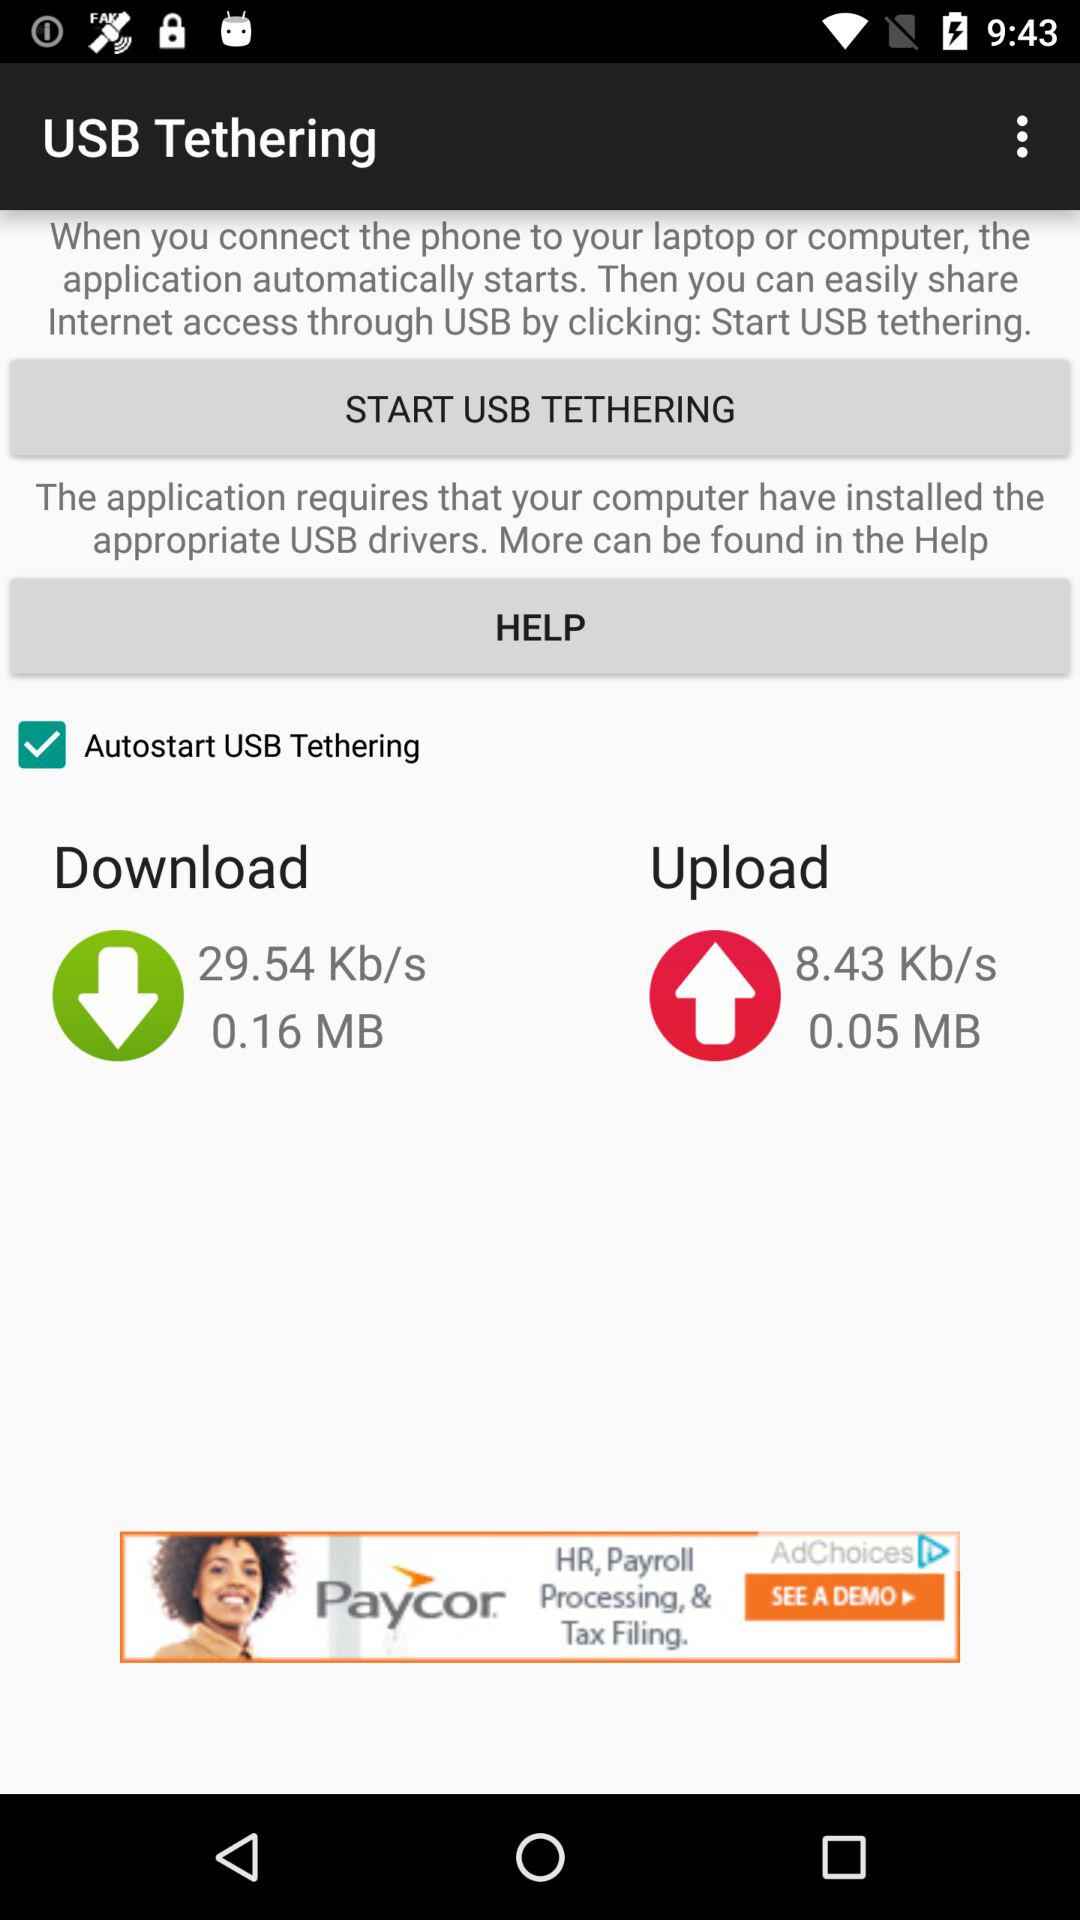How many MB have been downloaded? The MB that has been downloaded is 0.16. 